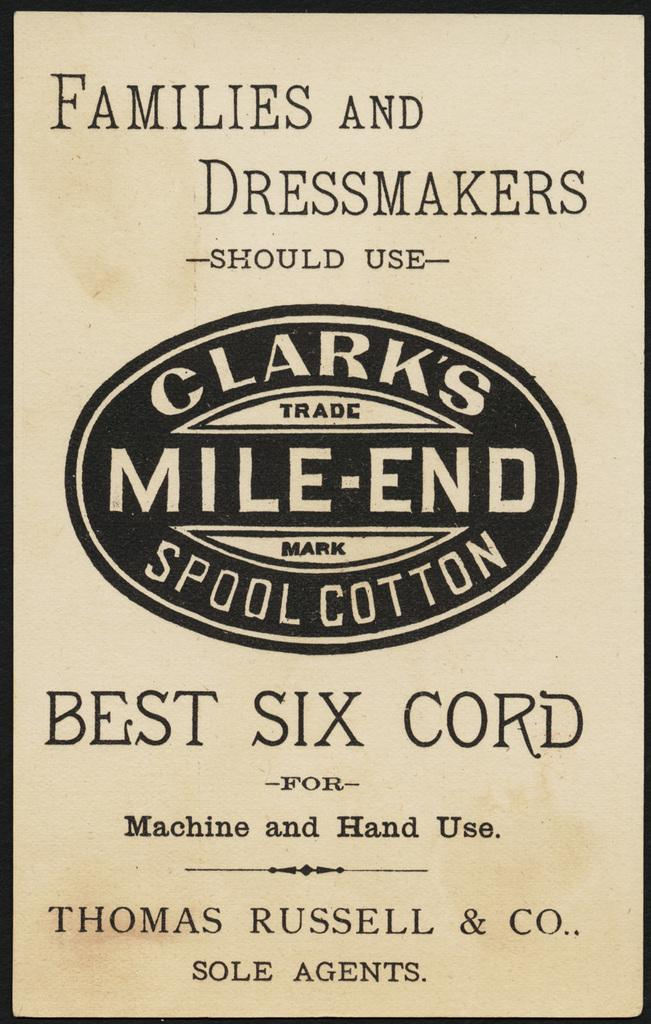What is present in the image that contains information or a message? There is a poster in the image that contains information or a message. What color is used for the text on the poster? The text on the poster is in black color. What other element in the image is in black color? There is a border line in black color in the image. What type of jam is being spread on the sink in the image? There is no jam or sink present in the image; it only contains a poster and a border line in black color. How does the poster show respect to the audience in the image? The poster does not show respect to the audience in the image, as the concept of respect is not related to the visual elements present in the image. 